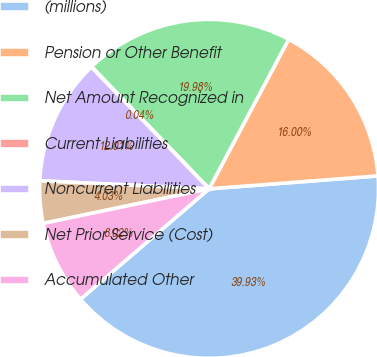Convert chart to OTSL. <chart><loc_0><loc_0><loc_500><loc_500><pie_chart><fcel>(millions)<fcel>Pension or Other Benefit<fcel>Net Amount Recognized in<fcel>Current Liabilities<fcel>Noncurrent Liabilities<fcel>Net Prior Service (Cost)<fcel>Accumulated Other<nl><fcel>39.93%<fcel>16.0%<fcel>19.98%<fcel>0.04%<fcel>12.01%<fcel>4.03%<fcel>8.02%<nl></chart> 